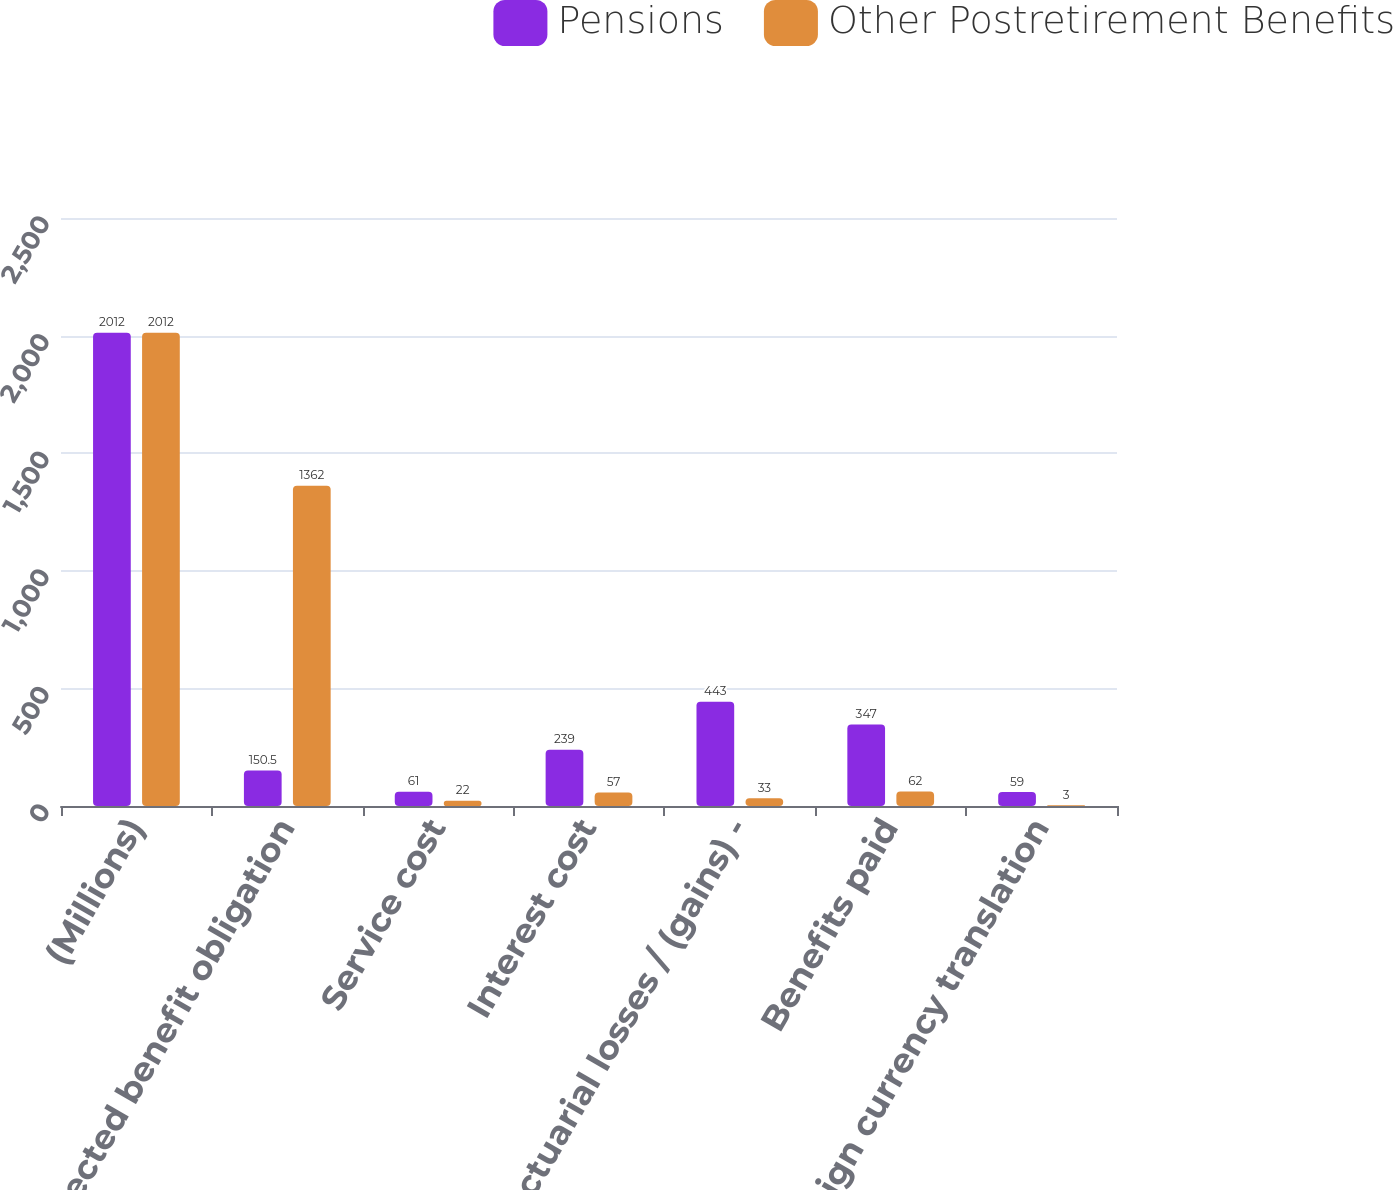Convert chart. <chart><loc_0><loc_0><loc_500><loc_500><stacked_bar_chart><ecel><fcel>(Millions)<fcel>Projected benefit obligation<fcel>Service cost<fcel>Interest cost<fcel>Actuarial losses / (gains) -<fcel>Benefits paid<fcel>Foreign currency translation<nl><fcel>Pensions<fcel>2012<fcel>150.5<fcel>61<fcel>239<fcel>443<fcel>347<fcel>59<nl><fcel>Other Postretirement Benefits<fcel>2012<fcel>1362<fcel>22<fcel>57<fcel>33<fcel>62<fcel>3<nl></chart> 